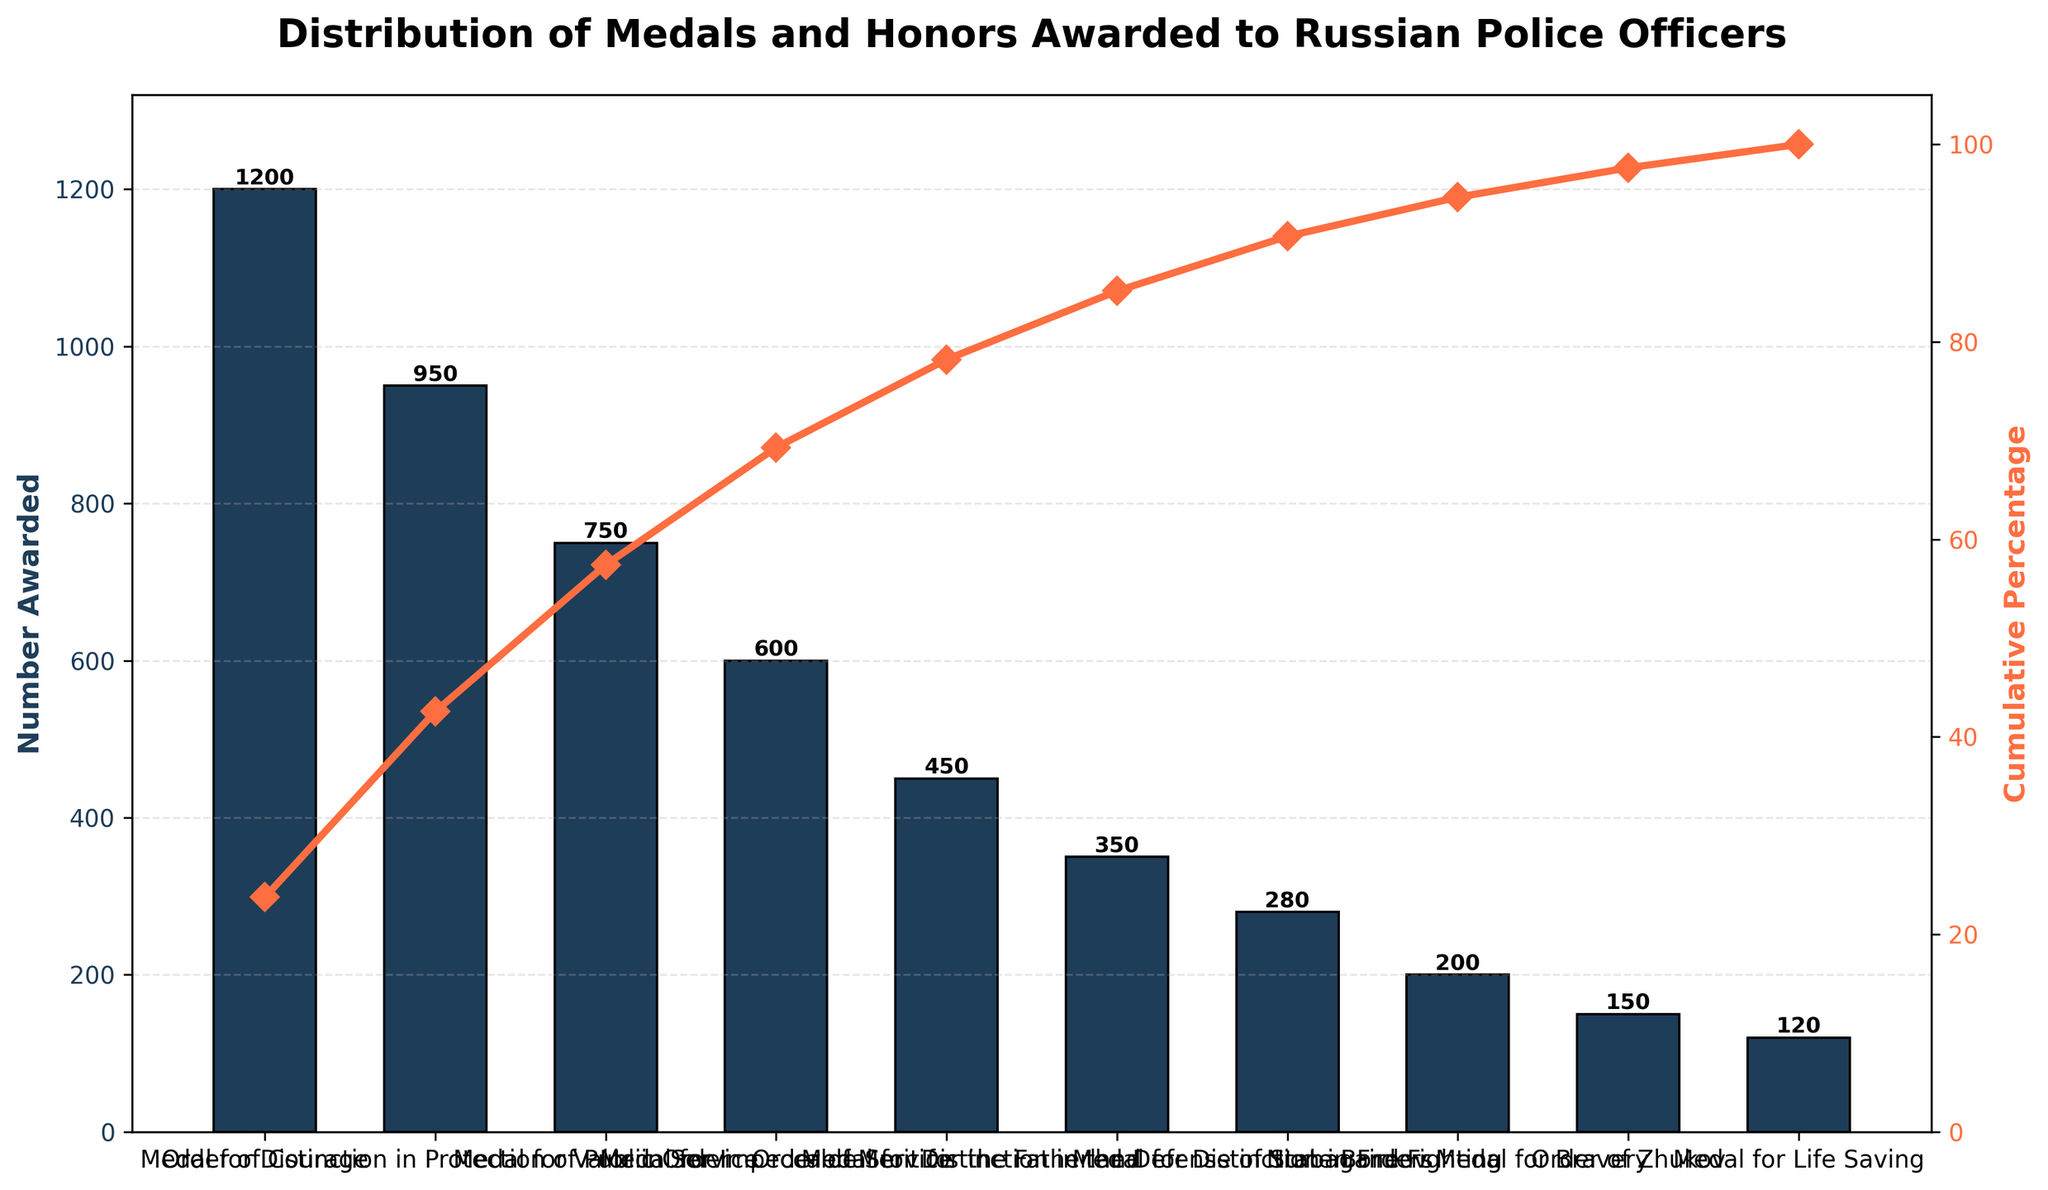How many medals were awarded for Valor in Service? The "Medal for Valor in Service" bar shows the number of medals awarded.
Answer: 750 What is the title of the figure? The title is located at the top of the figure.
Answer: Distribution of Medals and Honors Awarded to Russian Police Officers How many different types of medals and honors have been awarded? Count the number of bars in the bar chart, which corresponds to different medals and honors.
Answer: 10 What is the cumulative percentage of medals awarded up to and including the "Medal for Distinction in Fire Fighting"? Identify the cumulative percentage line that aligns with the "Medal for Distinction in Fire Fighting" and read the value from the secondary y-axis (right side).
Answer: Approximately 92% Which medal/honor has the least number of awards? Identify the shortest bar in the chart and read its label.
Answer: Medal for Life Saving What is the total number of medals awarded? Sum all the values from the bars (1200 + 950 + 750 + 600 + 450 + 350 + 280 + 200 + 150 + 120).
Answer: 5050 By how many medals does the "Order of Courage" exceed the "Order of Merit for the Fatherland"? Subtract the number of "Order of Merit for the Fatherland" medals from the "Order of Courage" medals (1200 - 450).
Answer: 750 What percentage of the total medals does the "Medal for Impeccable Service" represent? Divide the number awarded for "Medal for Impeccable Service" by the total number of medals and multiply by 100 (600 / 5050 * 100).
Answer: Approximately 11.88% How does the cumulative percentage curve help in understanding the distribution of medals? It shows the accumulating percentage relative to the total number of medals awarded, and helps identify from which point the lesser awarded medals start contributing.
Answer: It highlights the distribution where the majority of medals concentrate Is the cumulative percentage line steep or gradual after the "Order of Merit for the Fatherland"? Observe the gradient of the cumulative percentage line after the "Order of Merit for the Fatherland" at its right up to the end.
Answer: Gradual 